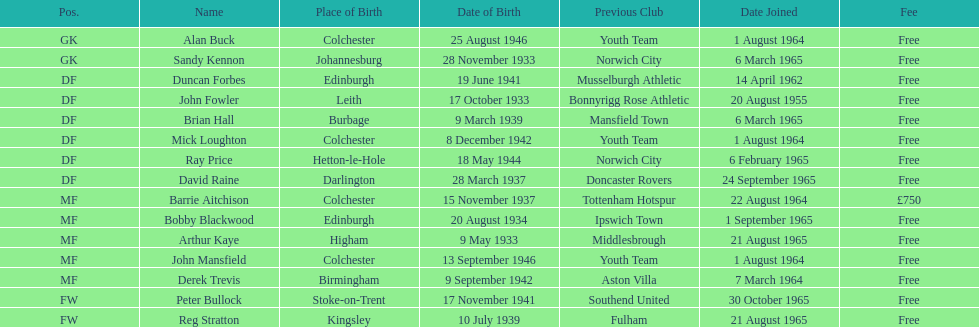What is the date when the first player joined? 20 August 1955. 